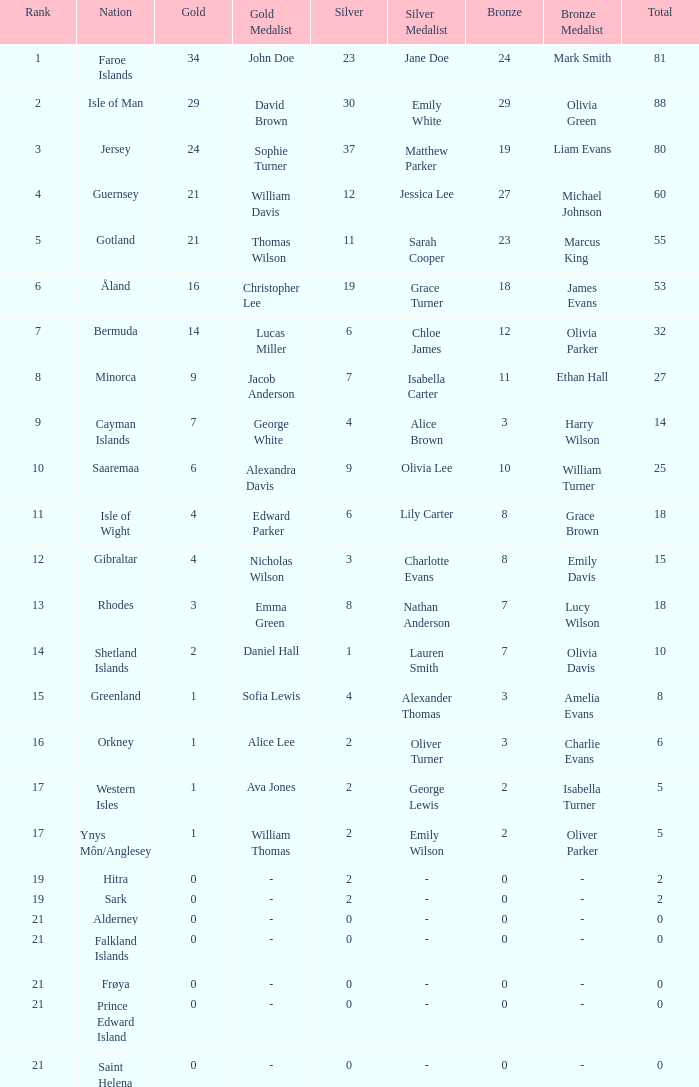How many Silver medals were won in total by all those with more than 3 bronze and exactly 16 gold? 19.0. 